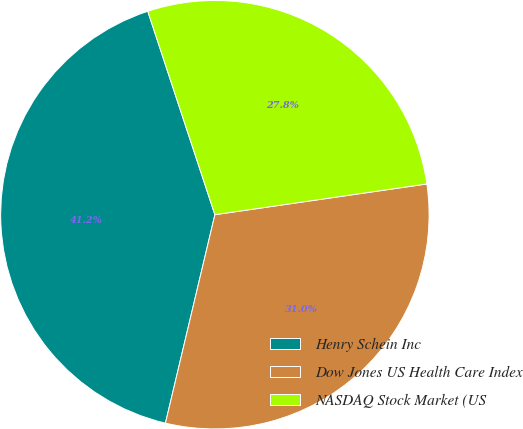Convert chart to OTSL. <chart><loc_0><loc_0><loc_500><loc_500><pie_chart><fcel>Henry Schein Inc<fcel>Dow Jones US Health Care Index<fcel>NASDAQ Stock Market (US<nl><fcel>41.22%<fcel>31.0%<fcel>27.78%<nl></chart> 